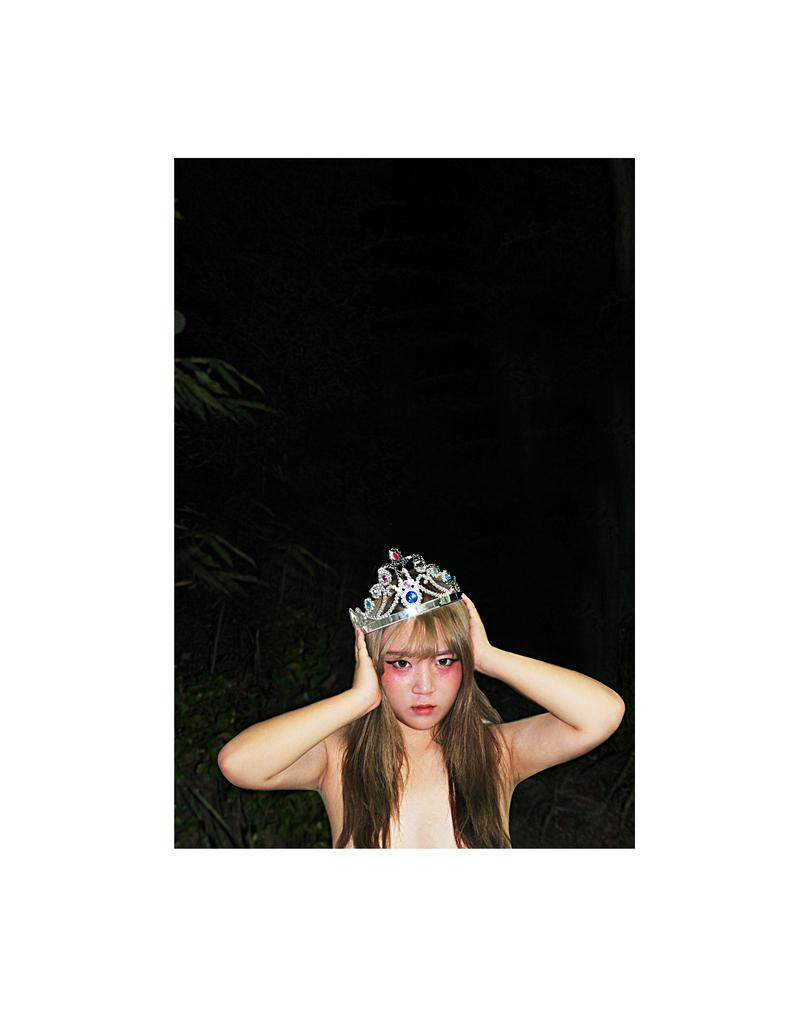Who is the main subject in the image? There is a woman in the image. What is the woman doing in the image? The woman is standing. What can be seen in the background of the image? There are trees visible in the background of the image. What position does the woman's son hold in the image? There is no mention of a son in the image, so it is not possible to determine his position. 